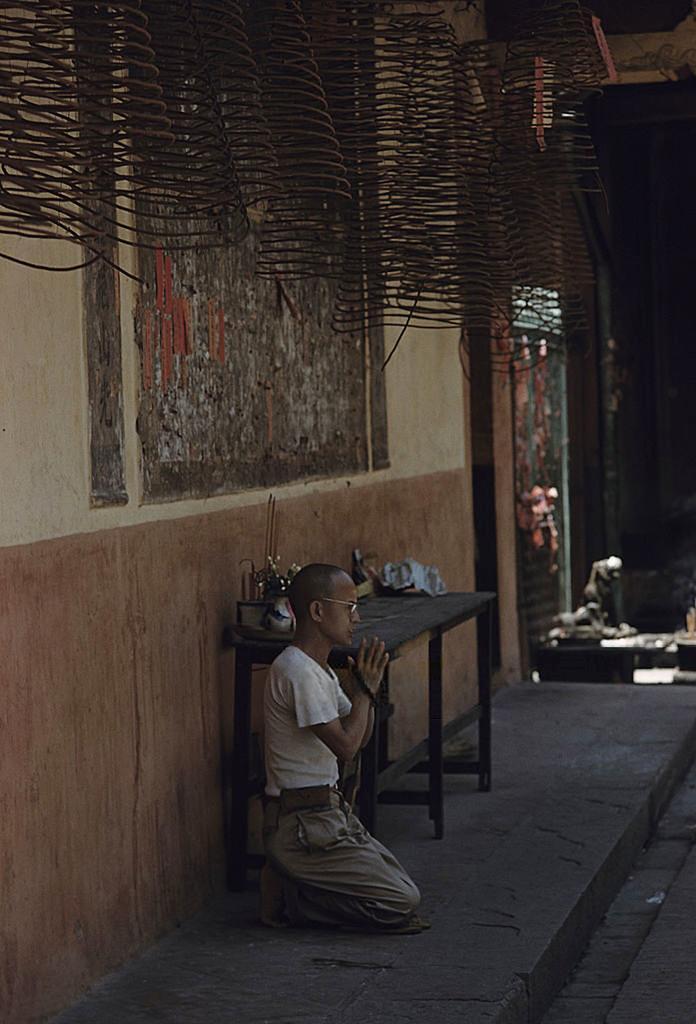Please provide a concise description of this image. In this picture we can see a person sitting and praying on the path. There is a box and few other things on the table. We can see some coiled metal objects on top. 